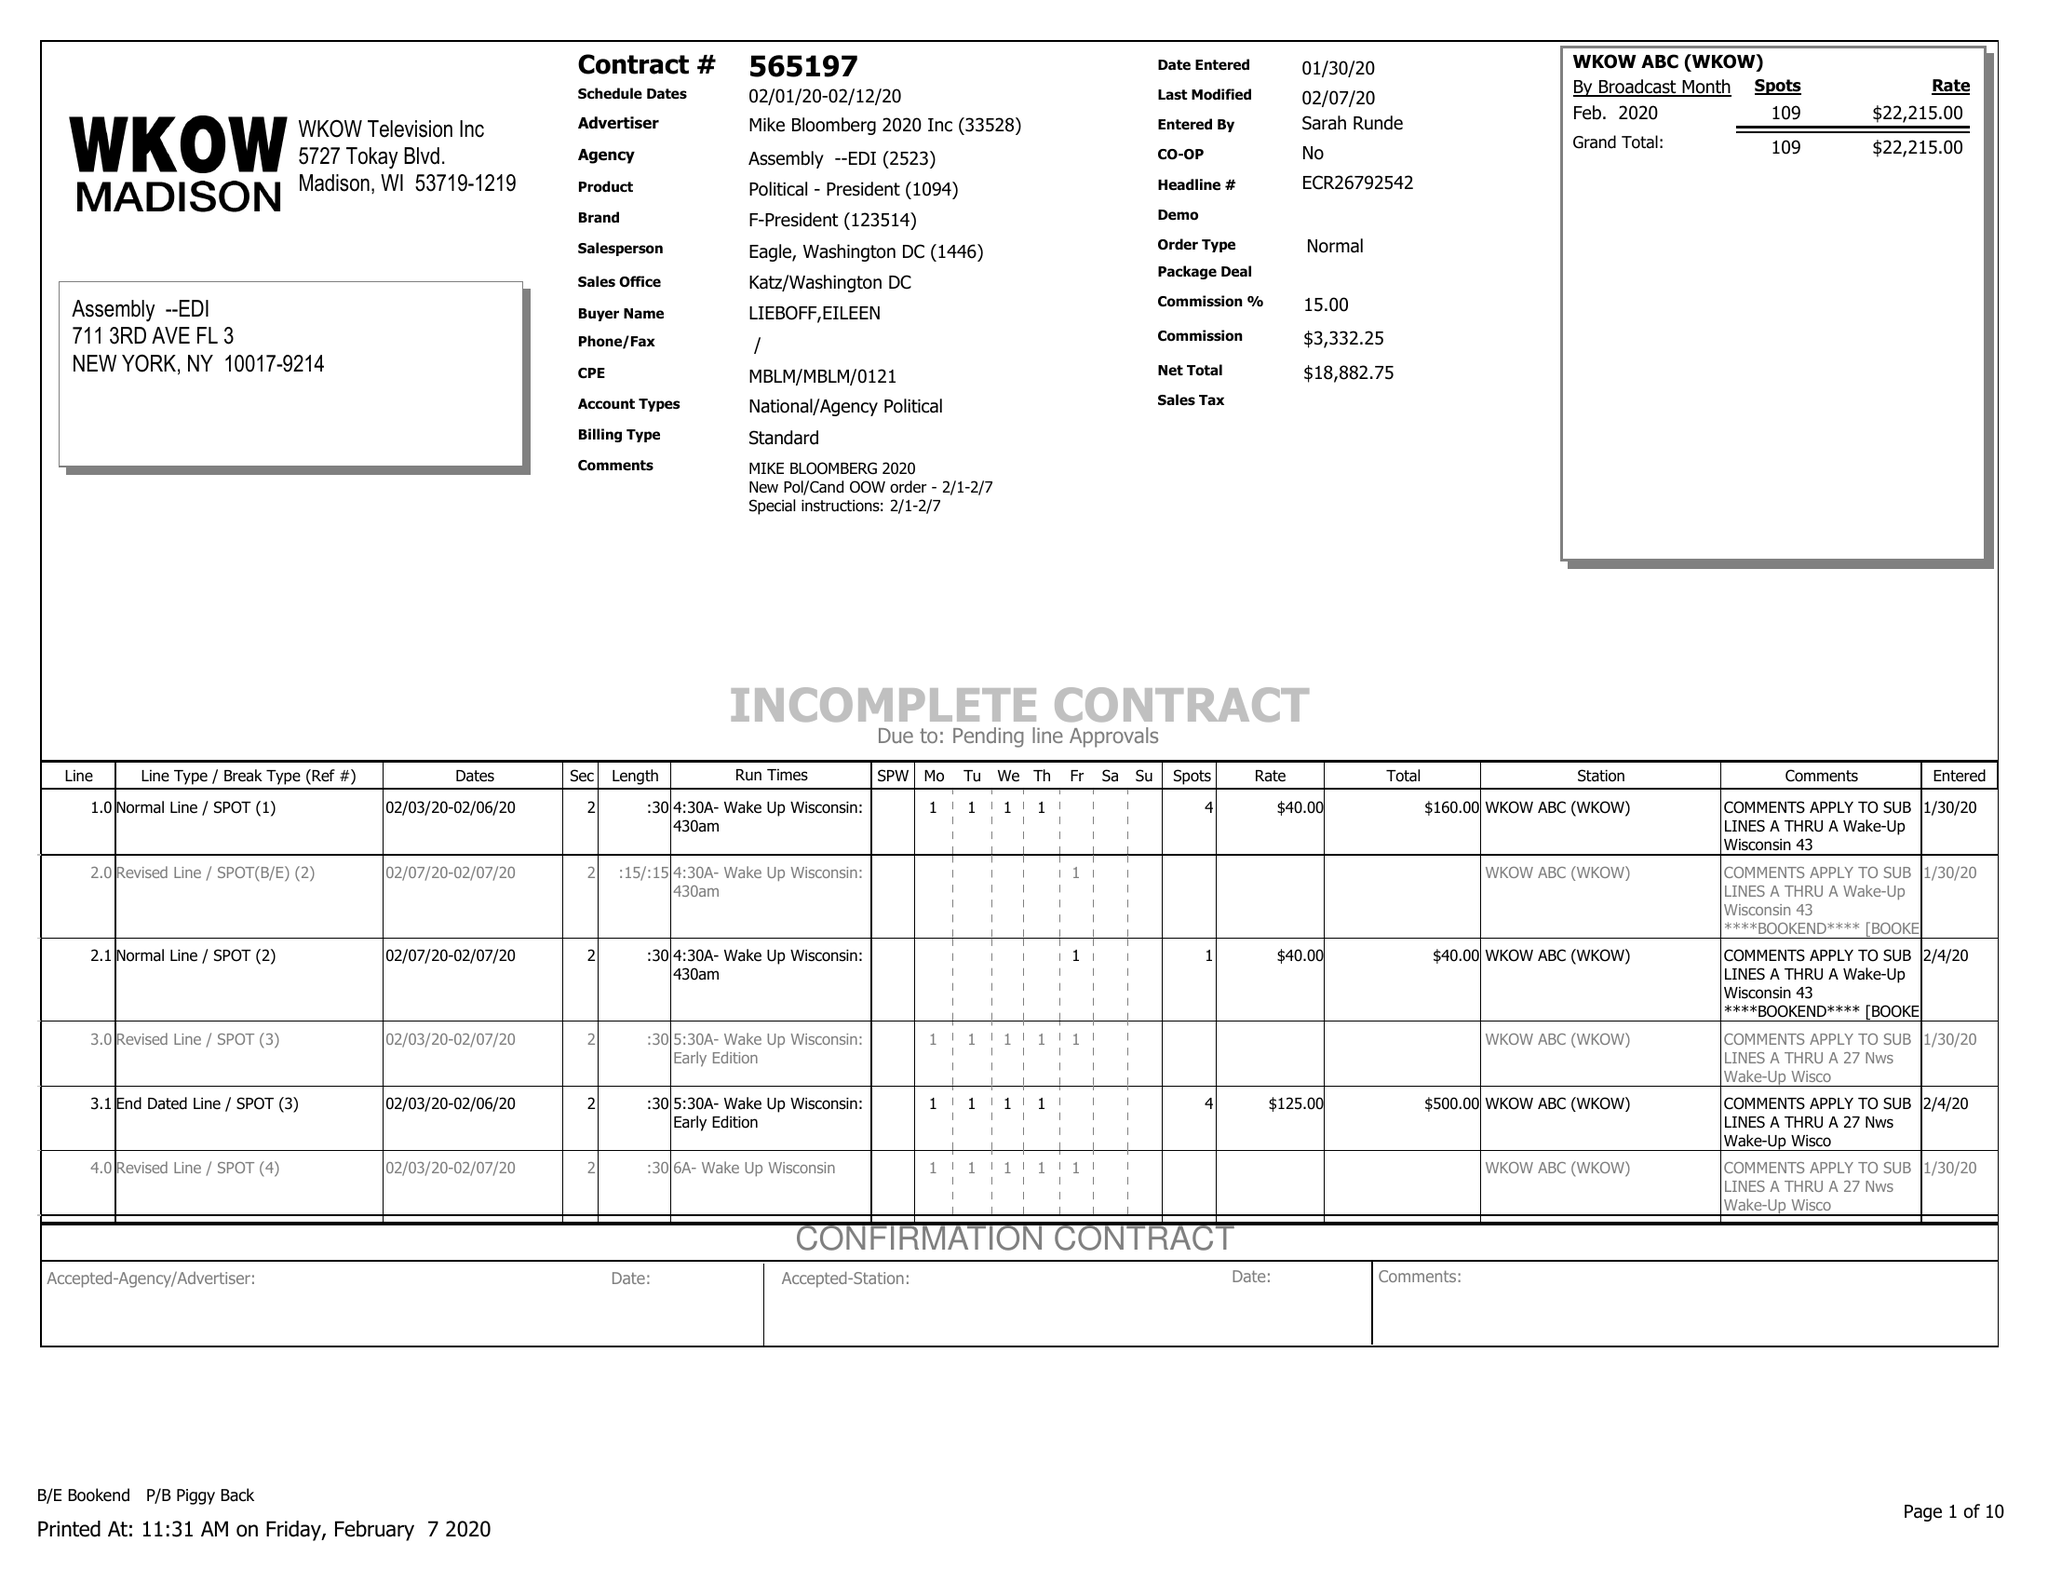What is the value for the flight_from?
Answer the question using a single word or phrase. 02/01/20 